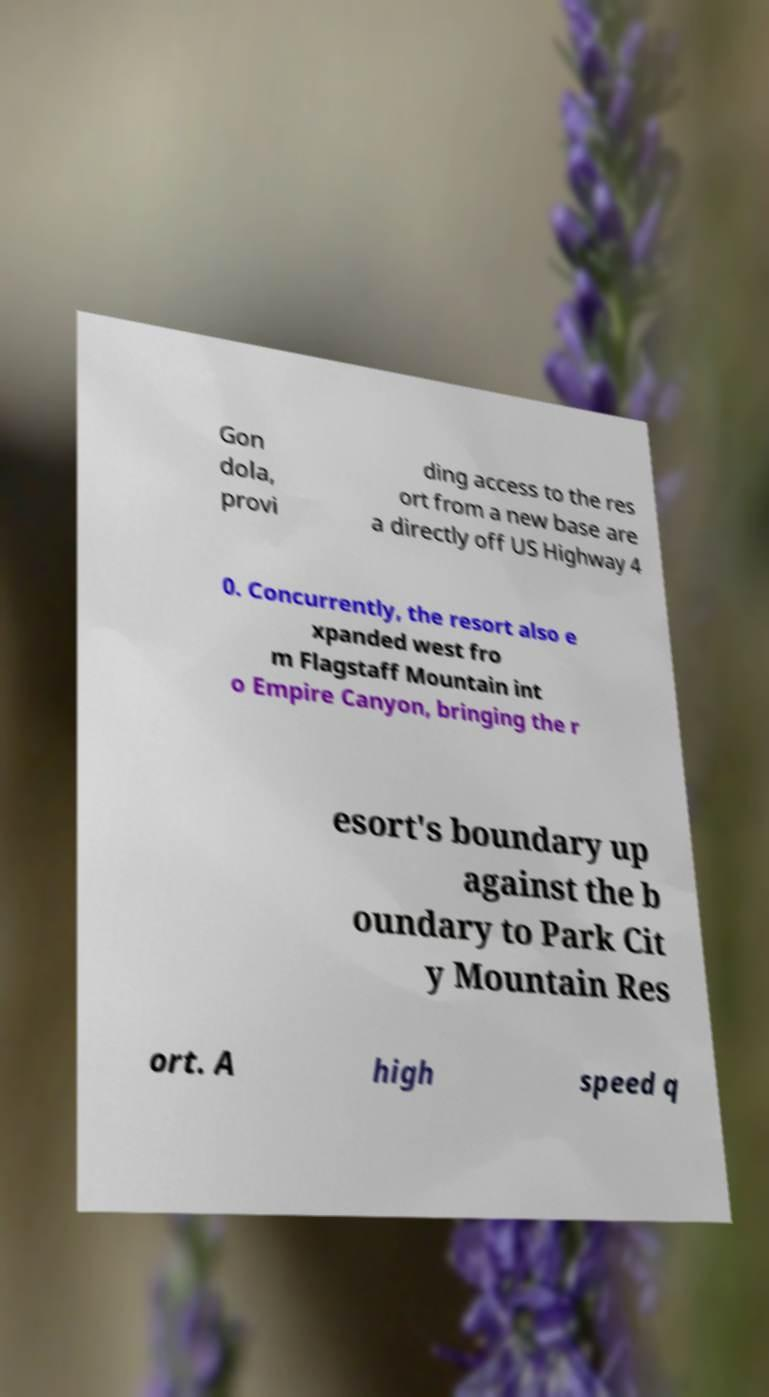Could you extract and type out the text from this image? Gon dola, provi ding access to the res ort from a new base are a directly off US Highway 4 0. Concurrently, the resort also e xpanded west fro m Flagstaff Mountain int o Empire Canyon, bringing the r esort's boundary up against the b oundary to Park Cit y Mountain Res ort. A high speed q 